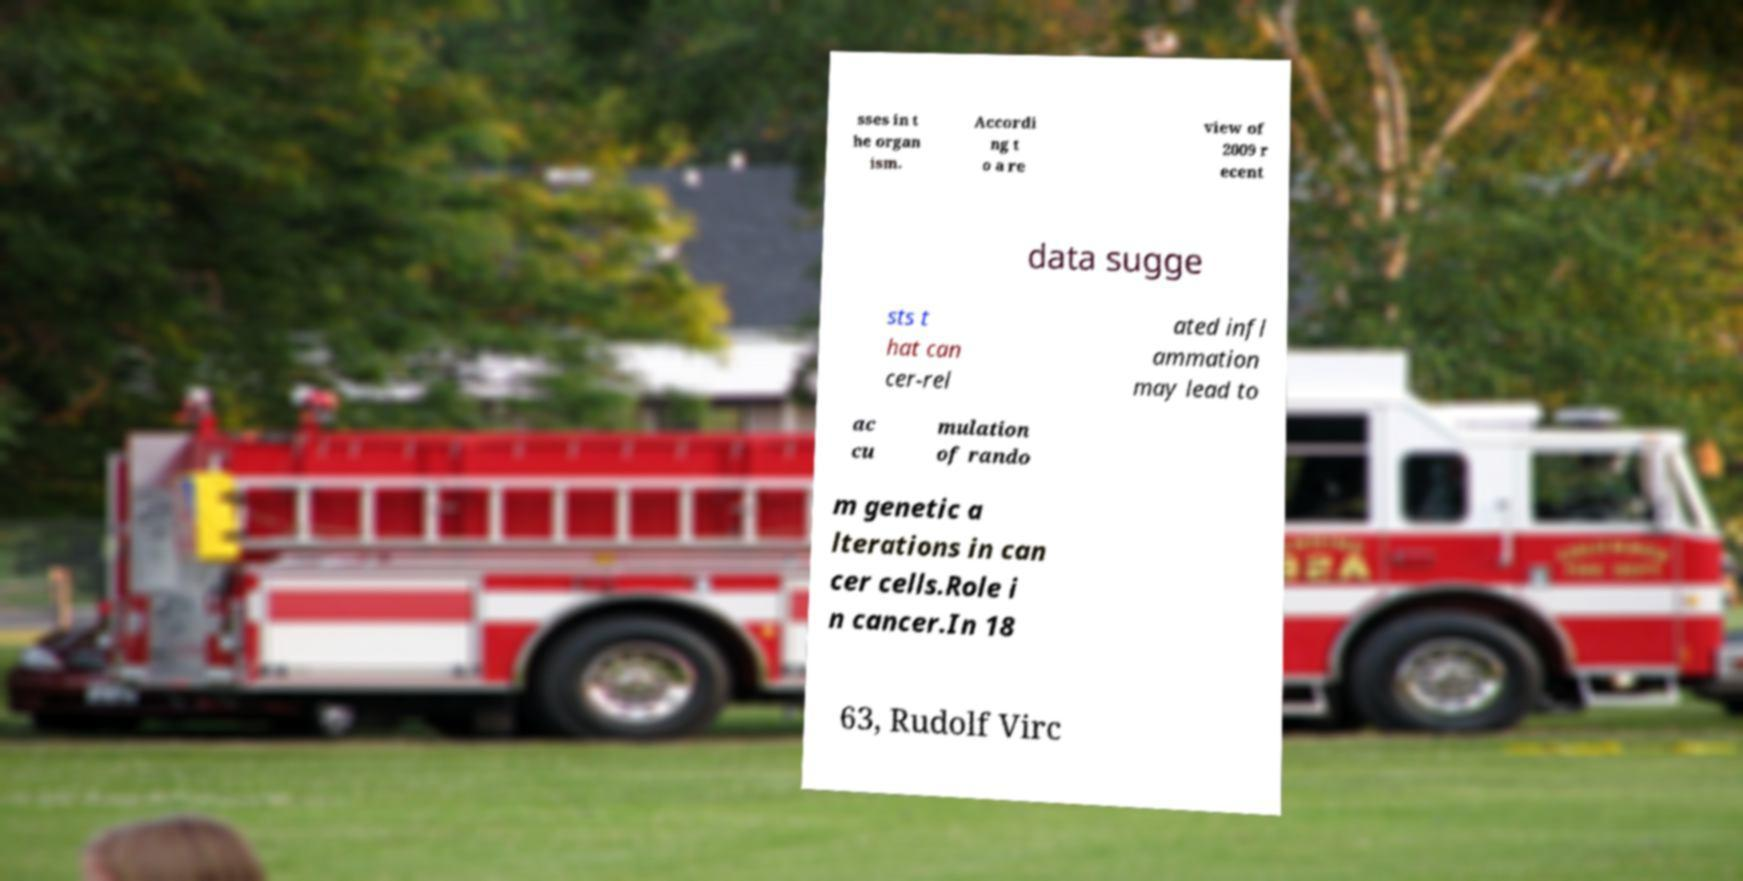Please identify and transcribe the text found in this image. sses in t he organ ism. Accordi ng t o a re view of 2009 r ecent data sugge sts t hat can cer-rel ated infl ammation may lead to ac cu mulation of rando m genetic a lterations in can cer cells.Role i n cancer.In 18 63, Rudolf Virc 